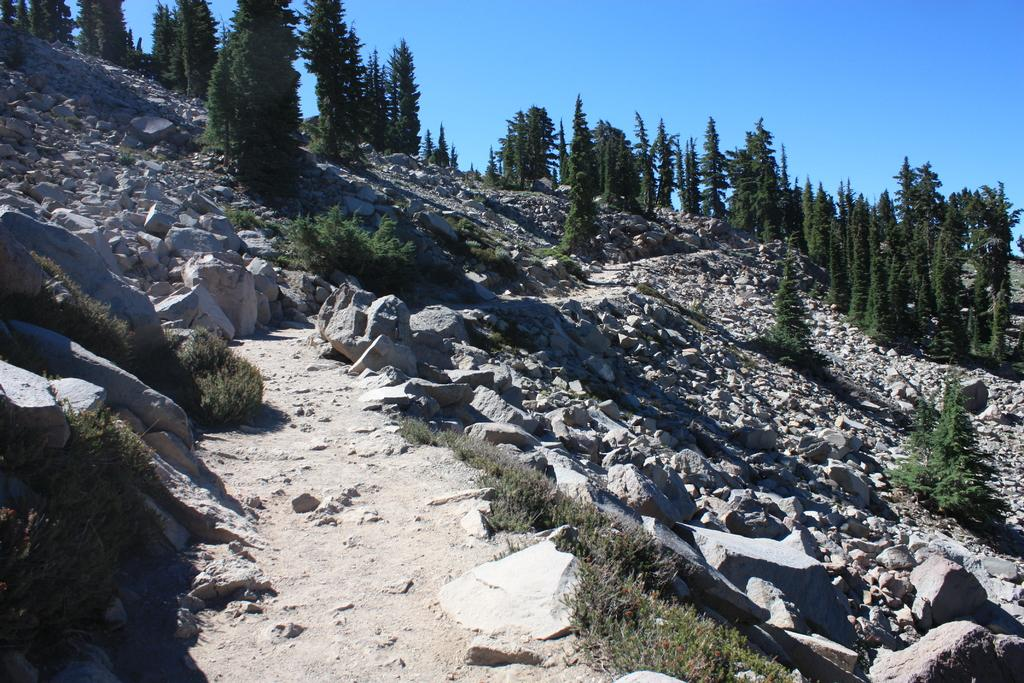What types of surfaces are present at the bottom of the image? There are rocks, grass, and sand at the bottom of the image. What type of vegetation can be seen in the background of the image? There are trees in the background of the image. What is visible at the top of the image? The sky is visible at the top of the image. What is the price of the apparatus in the image? There is no apparatus present in the image, so it is not possible to determine its price. 